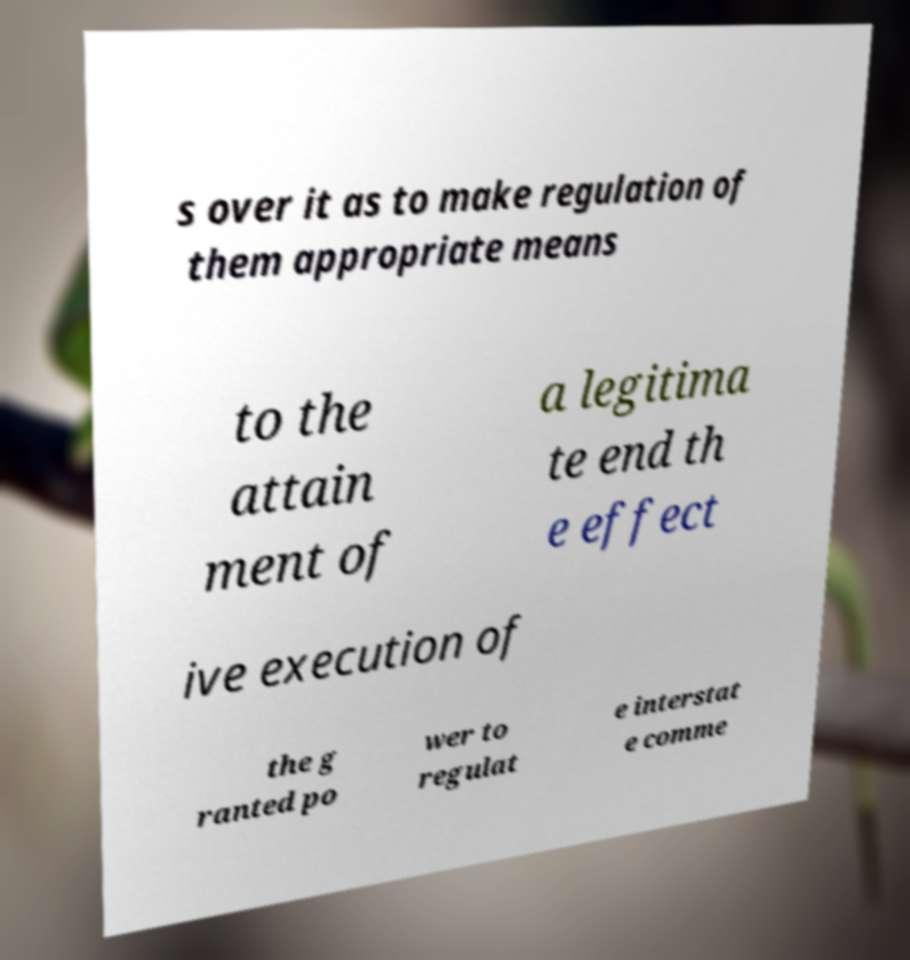Can you accurately transcribe the text from the provided image for me? s over it as to make regulation of them appropriate means to the attain ment of a legitima te end th e effect ive execution of the g ranted po wer to regulat e interstat e comme 